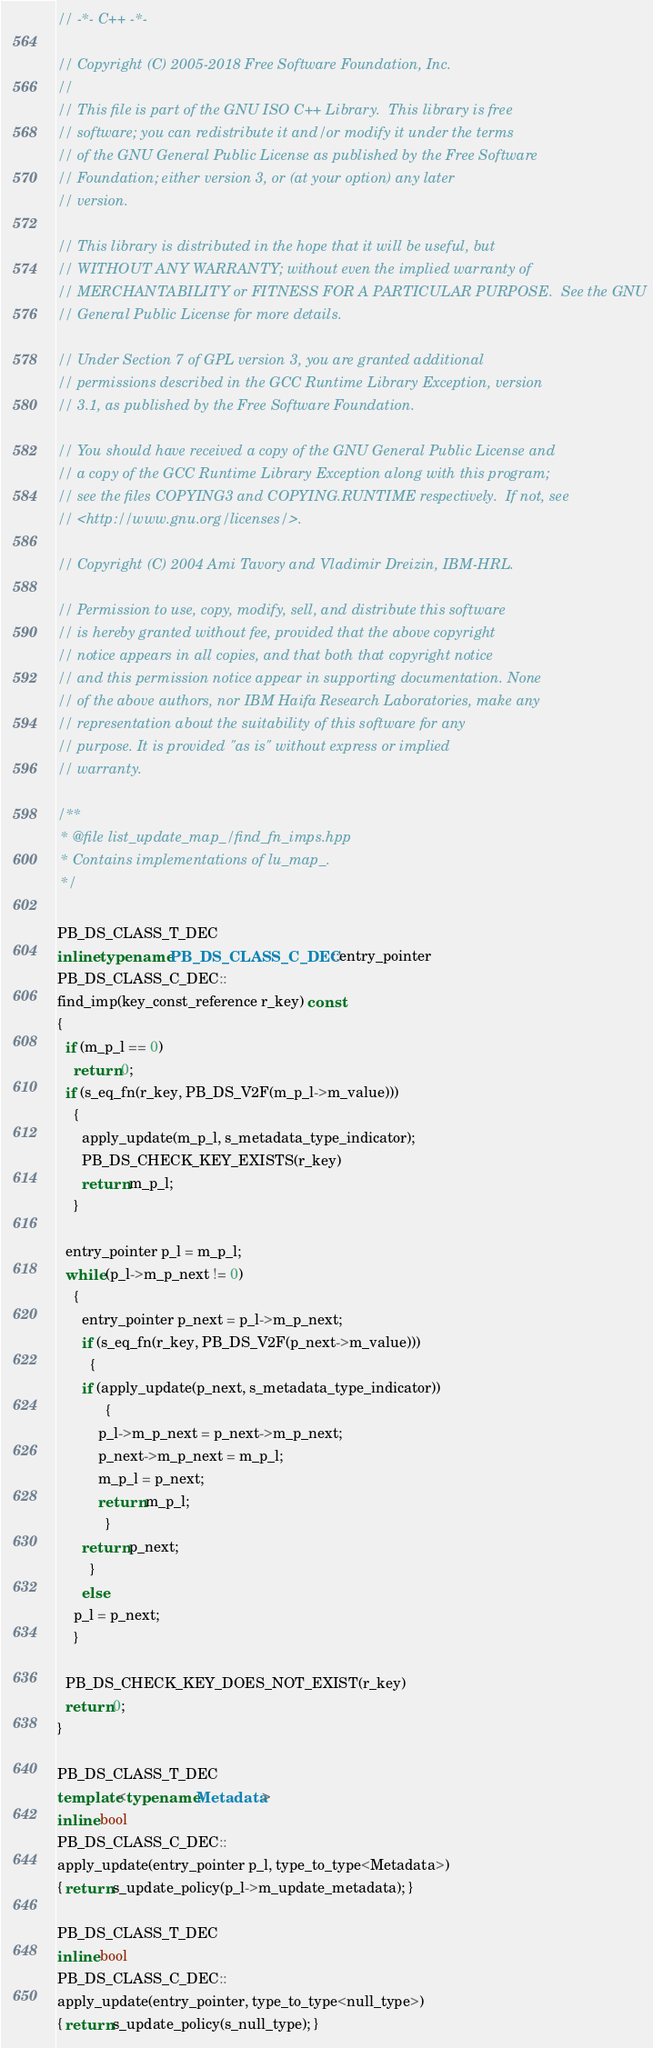<code> <loc_0><loc_0><loc_500><loc_500><_C++_>// -*- C++ -*-

// Copyright (C) 2005-2018 Free Software Foundation, Inc.
//
// This file is part of the GNU ISO C++ Library.  This library is free
// software; you can redistribute it and/or modify it under the terms
// of the GNU General Public License as published by the Free Software
// Foundation; either version 3, or (at your option) any later
// version.

// This library is distributed in the hope that it will be useful, but
// WITHOUT ANY WARRANTY; without even the implied warranty of
// MERCHANTABILITY or FITNESS FOR A PARTICULAR PURPOSE.  See the GNU
// General Public License for more details.

// Under Section 7 of GPL version 3, you are granted additional
// permissions described in the GCC Runtime Library Exception, version
// 3.1, as published by the Free Software Foundation.

// You should have received a copy of the GNU General Public License and
// a copy of the GCC Runtime Library Exception along with this program;
// see the files COPYING3 and COPYING.RUNTIME respectively.  If not, see
// <http://www.gnu.org/licenses/>.

// Copyright (C) 2004 Ami Tavory and Vladimir Dreizin, IBM-HRL.

// Permission to use, copy, modify, sell, and distribute this software
// is hereby granted without fee, provided that the above copyright
// notice appears in all copies, and that both that copyright notice
// and this permission notice appear in supporting documentation. None
// of the above authors, nor IBM Haifa Research Laboratories, make any
// representation about the suitability of this software for any
// purpose. It is provided "as is" without express or implied
// warranty.

/**
 * @file list_update_map_/find_fn_imps.hpp
 * Contains implementations of lu_map_.
 */

PB_DS_CLASS_T_DEC
inline typename PB_DS_CLASS_C_DEC::entry_pointer
PB_DS_CLASS_C_DEC::
find_imp(key_const_reference r_key) const
{
  if (m_p_l == 0)
    return 0;
  if (s_eq_fn(r_key, PB_DS_V2F(m_p_l->m_value)))
    {
      apply_update(m_p_l, s_metadata_type_indicator);
      PB_DS_CHECK_KEY_EXISTS(r_key)
      return m_p_l;
    }

  entry_pointer p_l = m_p_l;
  while (p_l->m_p_next != 0)
    {
      entry_pointer p_next = p_l->m_p_next;
      if (s_eq_fn(r_key, PB_DS_V2F(p_next->m_value)))
        {
	  if (apply_update(p_next, s_metadata_type_indicator))
            {
	      p_l->m_p_next = p_next->m_p_next;
	      p_next->m_p_next = m_p_l;
	      m_p_l = p_next;
	      return m_p_l;
            }
	  return p_next;
        }
      else
	p_l = p_next;
    }

  PB_DS_CHECK_KEY_DOES_NOT_EXIST(r_key)
  return 0;
}

PB_DS_CLASS_T_DEC
template<typename Metadata>
inline bool
PB_DS_CLASS_C_DEC::
apply_update(entry_pointer p_l, type_to_type<Metadata>)
{ return s_update_policy(p_l->m_update_metadata); }

PB_DS_CLASS_T_DEC
inline bool
PB_DS_CLASS_C_DEC::
apply_update(entry_pointer, type_to_type<null_type>)
{ return s_update_policy(s_null_type); }

</code> 